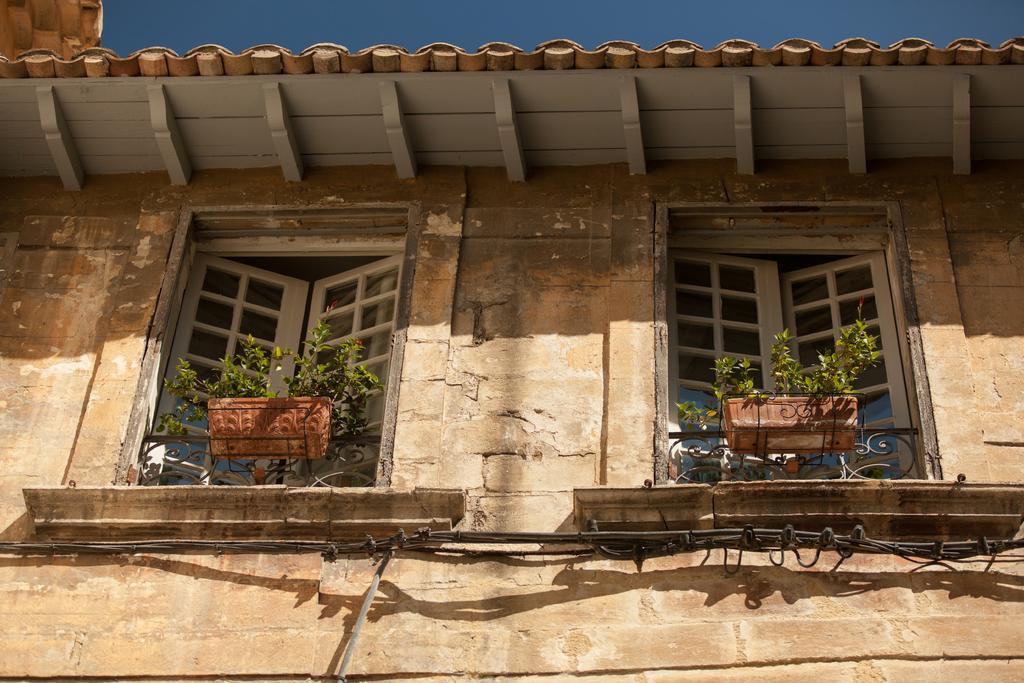How would you summarize this image in a sentence or two? In the image in the center we can see the sky,windows,plant pots,building,wall and roof. 